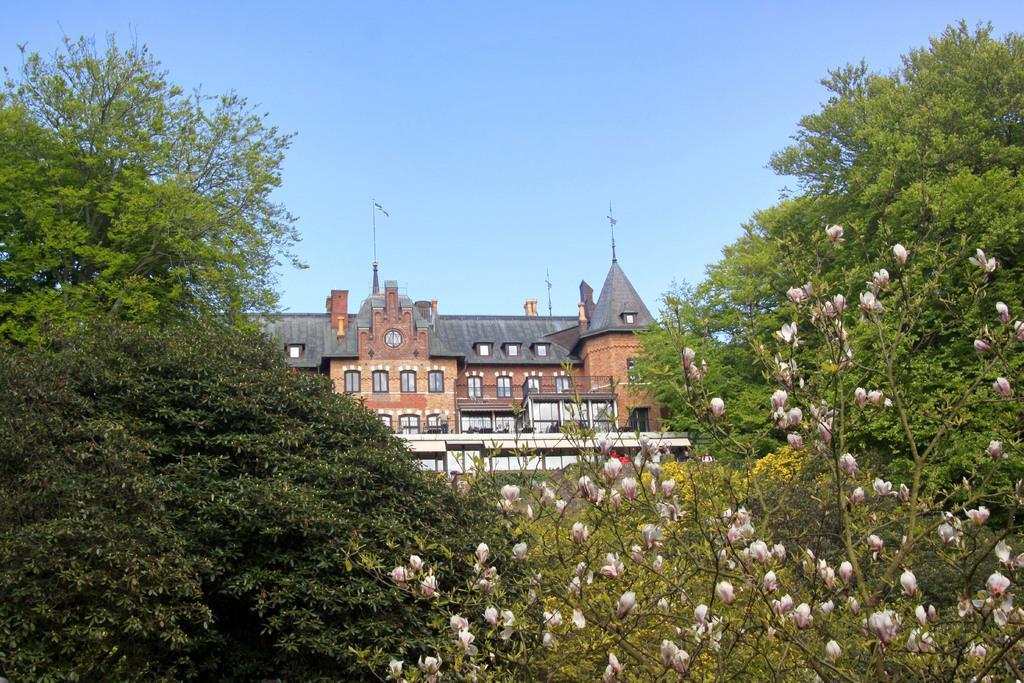Please provide a concise description of this image. In this picture we can see flowers, trees, building with windows and in the background we can see the sky. 